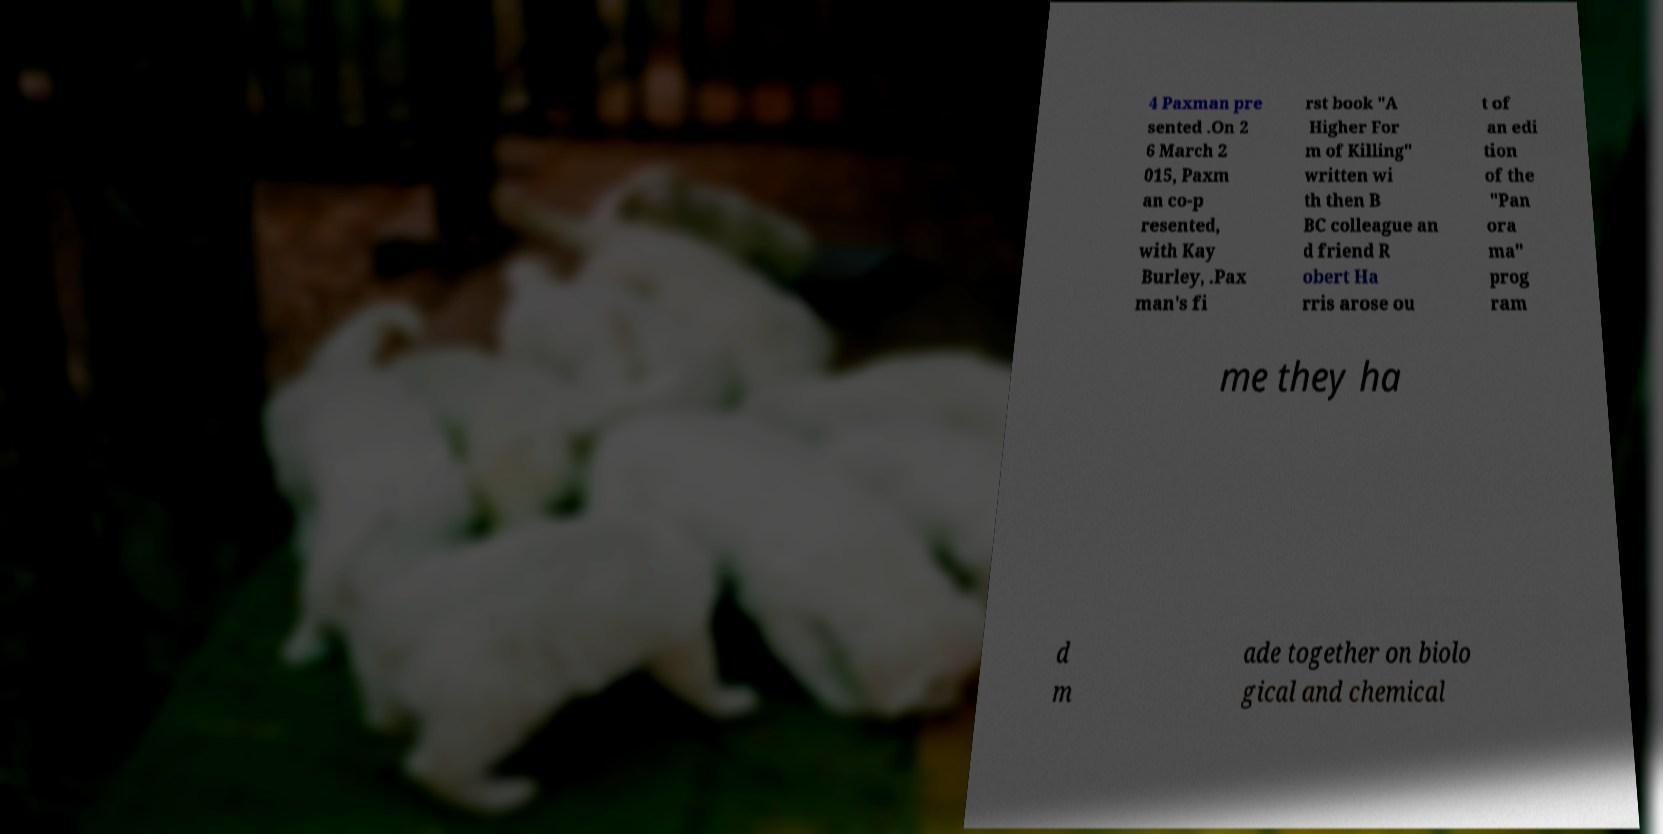Could you assist in decoding the text presented in this image and type it out clearly? 4 Paxman pre sented .On 2 6 March 2 015, Paxm an co-p resented, with Kay Burley, .Pax man's fi rst book "A Higher For m of Killing" written wi th then B BC colleague an d friend R obert Ha rris arose ou t of an edi tion of the "Pan ora ma" prog ram me they ha d m ade together on biolo gical and chemical 